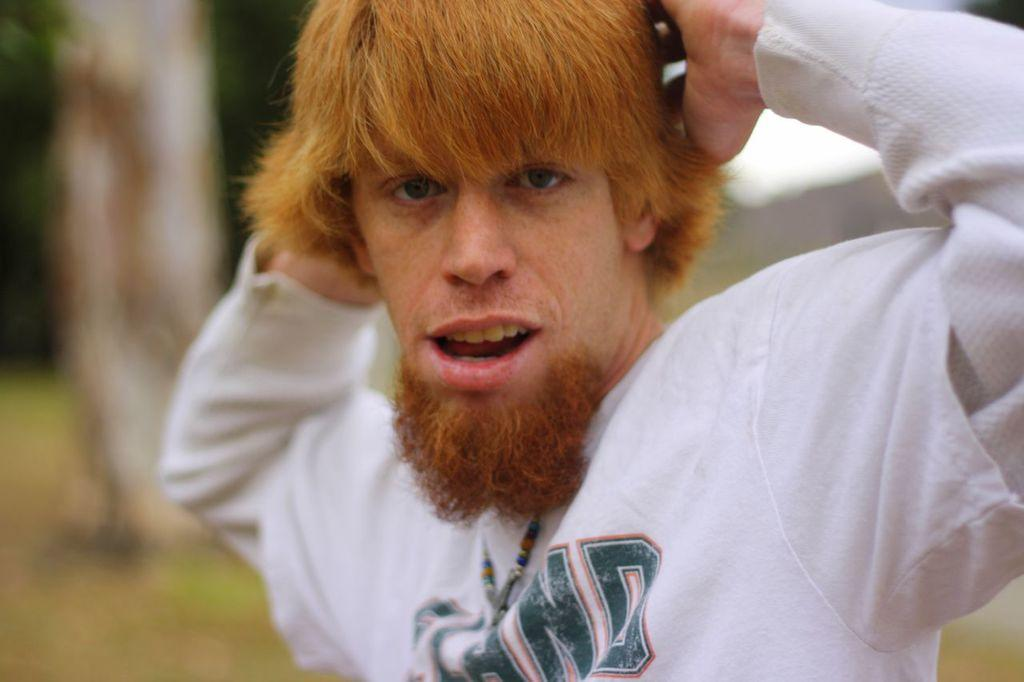Who or what is present in the image? There is a person in the image. What is the person wearing? The person is wearing a white shirt. What can be seen in the background of the image? There are trees in the background of the image. What is the color of the trees? The trees are green in color. How does the person in the image approve the use of ink? There is no mention of ink or approval in the image, so it cannot be determined from the image. 